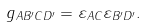<formula> <loc_0><loc_0><loc_500><loc_500>g _ { A B ^ { \prime } C D ^ { \prime } } = \varepsilon _ { A C } \varepsilon _ { B ^ { \prime } D ^ { \prime } } .</formula> 